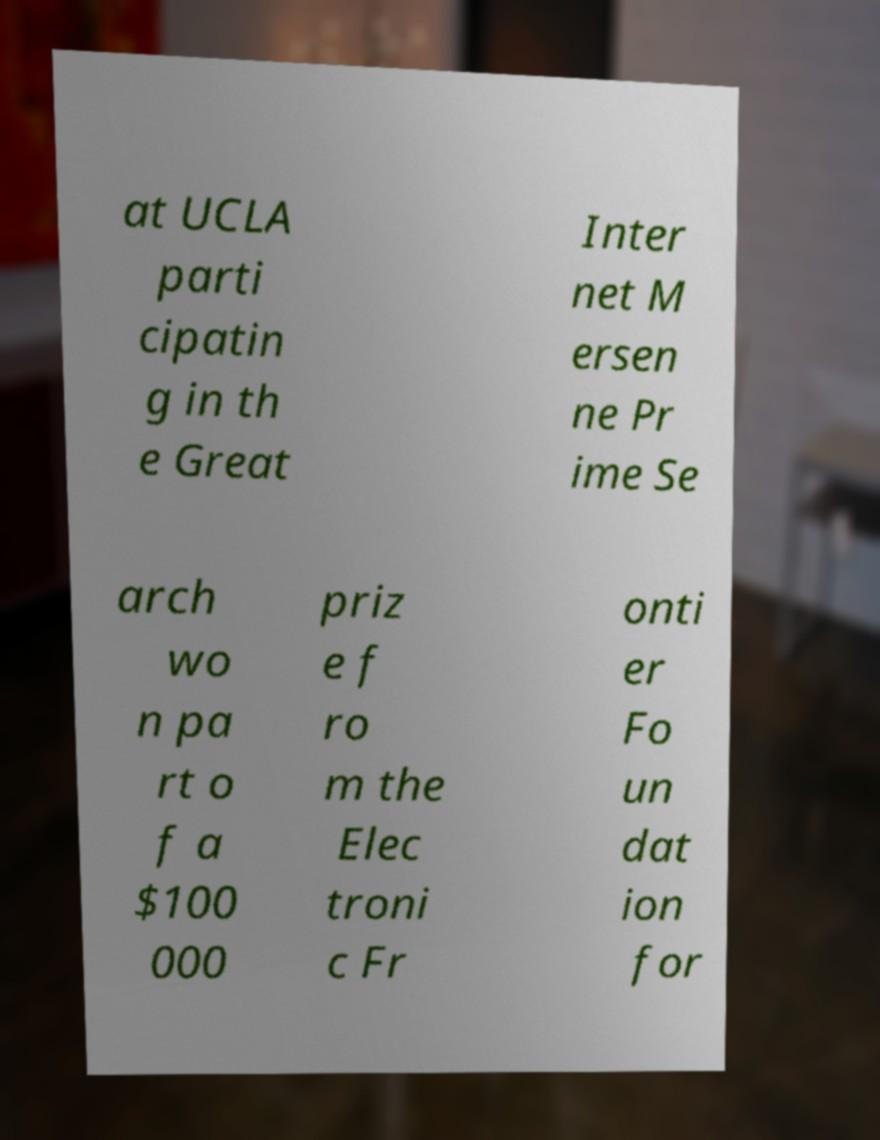Can you read and provide the text displayed in the image?This photo seems to have some interesting text. Can you extract and type it out for me? at UCLA parti cipatin g in th e Great Inter net M ersen ne Pr ime Se arch wo n pa rt o f a $100 000 priz e f ro m the Elec troni c Fr onti er Fo un dat ion for 